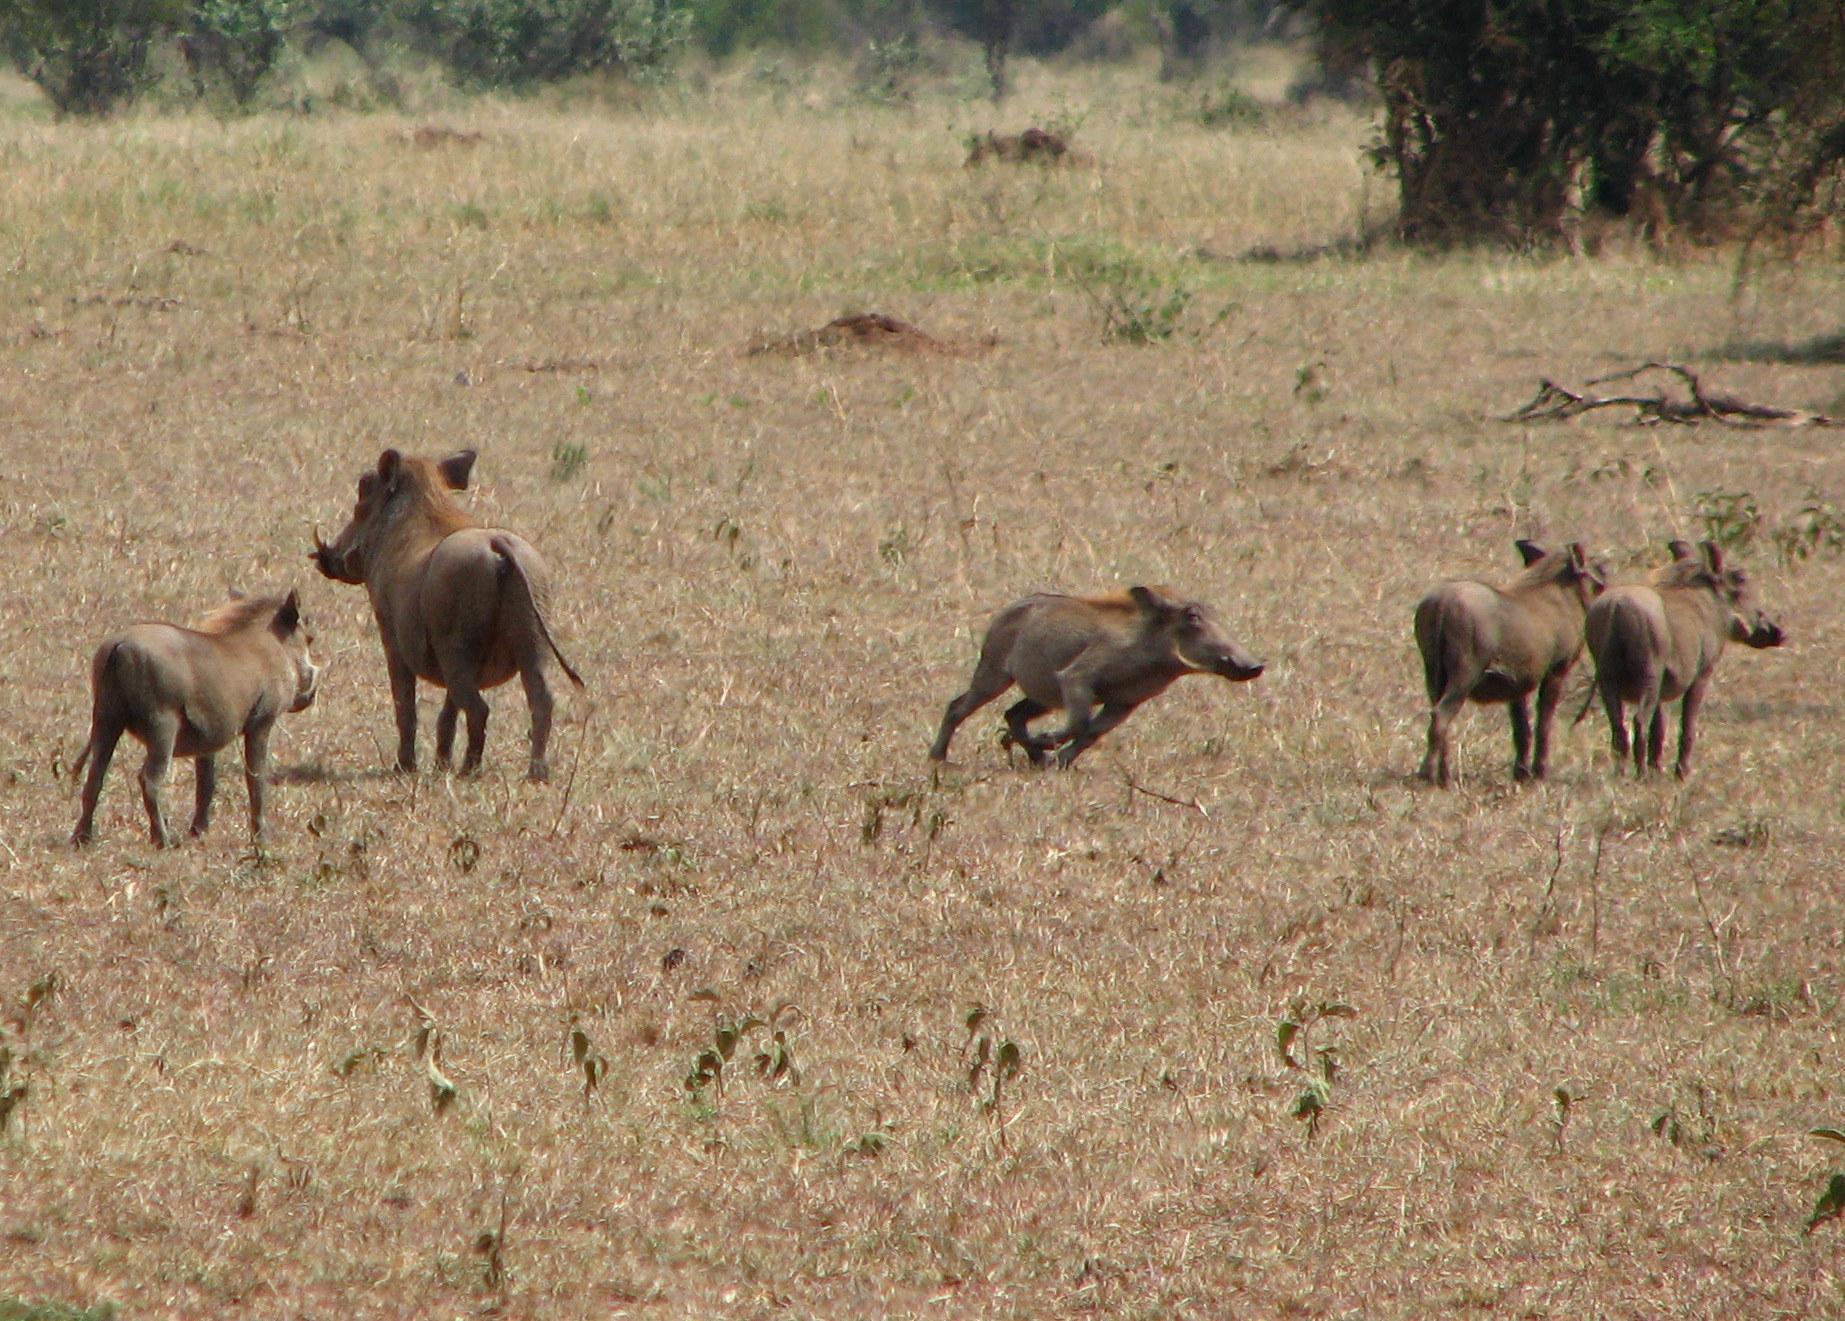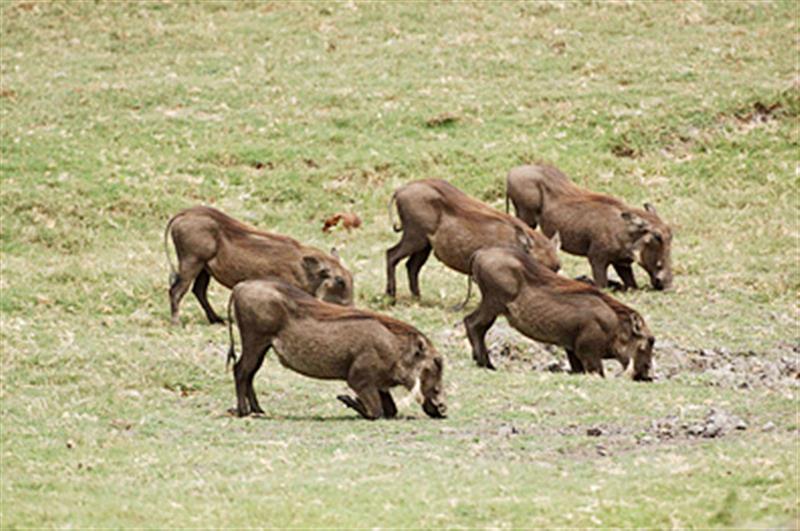The first image is the image on the left, the second image is the image on the right. Assess this claim about the two images: "There are 4 warthogs in the left image.". Correct or not? Answer yes or no. No. The first image is the image on the left, the second image is the image on the right. For the images shown, is this caption "one of the images shows a group of hogs standing and facing right." true? Answer yes or no. Yes. 